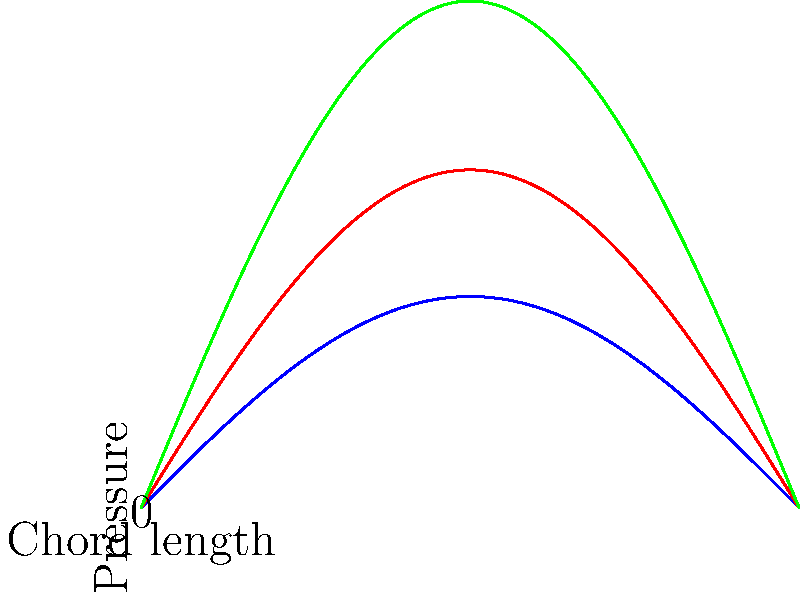As a political strategist focusing on the 2024 Los Angeles elections, you're preparing a presentation on local aerospace industry innovations. To demonstrate your technical knowledge, you need to explain the relationship between an airfoil's angle of attack and its pressure distribution. Based on the graph, which shows pressure distributions at different angles of attack (0°, 5°, and 10°), what general trend can be observed as the angle of attack increases? To answer this question, let's analyze the graph step-by-step:

1. The graph shows three curves representing pressure distributions along the chord length of an airfoil at different angles of attack: 0° (blue), 5° (red), and 10° (green).

2. The vertical axis represents pressure, while the horizontal axis represents the chord length of the airfoil.

3. For each angle of attack, the pressure distribution is shown as a sine-like curve, with negative pressure (suction) on the upper surface and positive pressure on the lower surface.

4. As we compare the curves from 0° to 5° to 10°, we can observe that:
   a. The amplitude of the curves increases.
   b. The area between the upper and lower parts of each curve grows larger.

5. This increase in amplitude and area indicates that:
   a. The pressure difference between the upper and lower surfaces of the airfoil becomes more pronounced.
   b. The suction on the upper surface intensifies.
   c. The positive pressure on the lower surface also increases.

6. In aerodynamics, a larger pressure difference between the upper and lower surfaces of an airfoil results in greater lift generation.

Therefore, the general trend observed as the angle of attack increases is that the pressure difference between the upper and lower surfaces of the airfoil becomes more pronounced, leading to increased lift generation.
Answer: Increasing pressure difference between upper and lower surfaces 